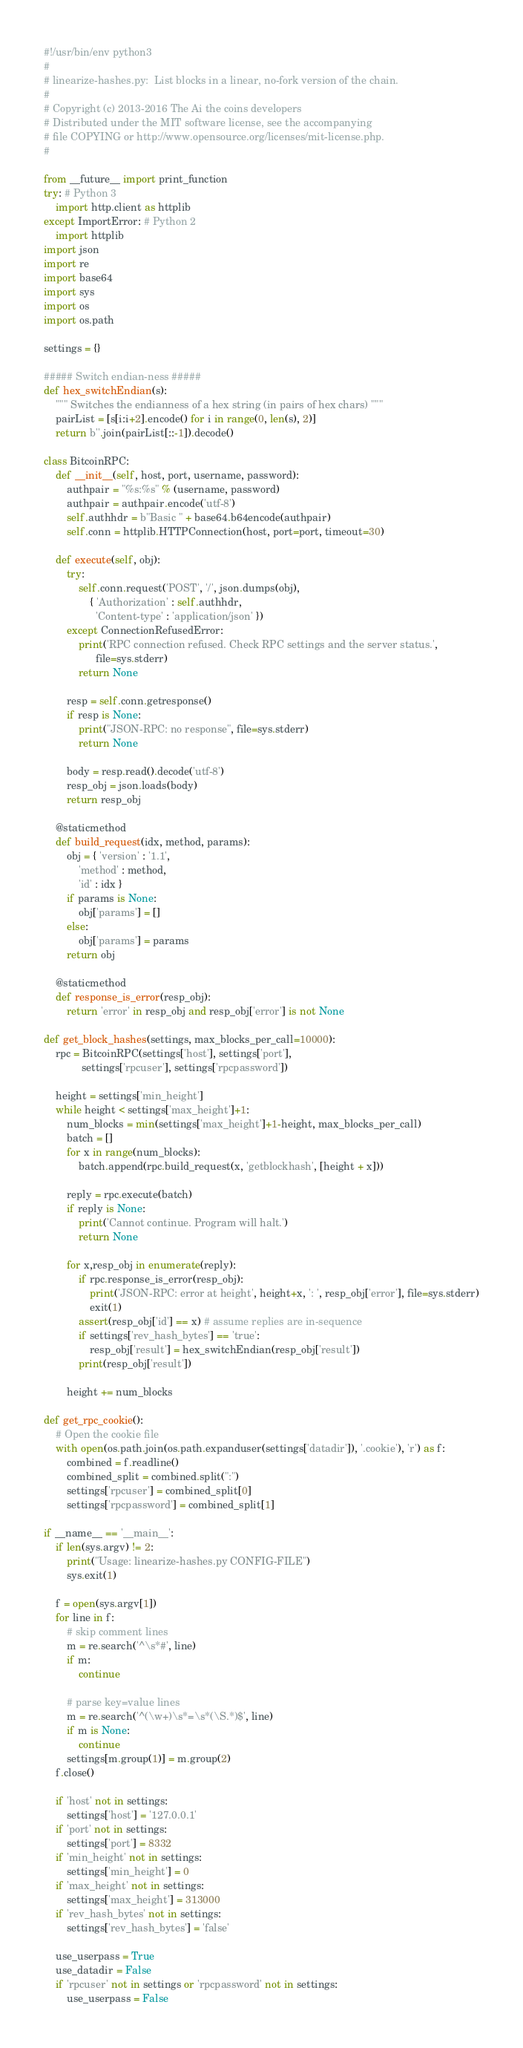Convert code to text. <code><loc_0><loc_0><loc_500><loc_500><_Python_>#!/usr/bin/env python3
#
# linearize-hashes.py:  List blocks in a linear, no-fork version of the chain.
#
# Copyright (c) 2013-2016 The Ai the coins developers
# Distributed under the MIT software license, see the accompanying
# file COPYING or http://www.opensource.org/licenses/mit-license.php.
#

from __future__ import print_function
try: # Python 3
    import http.client as httplib
except ImportError: # Python 2
    import httplib
import json
import re
import base64
import sys
import os
import os.path

settings = {}

##### Switch endian-ness #####
def hex_switchEndian(s):
	""" Switches the endianness of a hex string (in pairs of hex chars) """
	pairList = [s[i:i+2].encode() for i in range(0, len(s), 2)]
	return b''.join(pairList[::-1]).decode()

class BitcoinRPC:
	def __init__(self, host, port, username, password):
		authpair = "%s:%s" % (username, password)
		authpair = authpair.encode('utf-8')
		self.authhdr = b"Basic " + base64.b64encode(authpair)
		self.conn = httplib.HTTPConnection(host, port=port, timeout=30)

	def execute(self, obj):
		try:
			self.conn.request('POST', '/', json.dumps(obj),
				{ 'Authorization' : self.authhdr,
				  'Content-type' : 'application/json' })
		except ConnectionRefusedError:
			print('RPC connection refused. Check RPC settings and the server status.',
			      file=sys.stderr)
			return None

		resp = self.conn.getresponse()
		if resp is None:
			print("JSON-RPC: no response", file=sys.stderr)
			return None

		body = resp.read().decode('utf-8')
		resp_obj = json.loads(body)
		return resp_obj

	@staticmethod
	def build_request(idx, method, params):
		obj = { 'version' : '1.1',
			'method' : method,
			'id' : idx }
		if params is None:
			obj['params'] = []
		else:
			obj['params'] = params
		return obj

	@staticmethod
	def response_is_error(resp_obj):
		return 'error' in resp_obj and resp_obj['error'] is not None

def get_block_hashes(settings, max_blocks_per_call=10000):
	rpc = BitcoinRPC(settings['host'], settings['port'],
			 settings['rpcuser'], settings['rpcpassword'])

	height = settings['min_height']
	while height < settings['max_height']+1:
		num_blocks = min(settings['max_height']+1-height, max_blocks_per_call)
		batch = []
		for x in range(num_blocks):
			batch.append(rpc.build_request(x, 'getblockhash', [height + x]))

		reply = rpc.execute(batch)
		if reply is None:
			print('Cannot continue. Program will halt.')
			return None

		for x,resp_obj in enumerate(reply):
			if rpc.response_is_error(resp_obj):
				print('JSON-RPC: error at height', height+x, ': ', resp_obj['error'], file=sys.stderr)
				exit(1)
			assert(resp_obj['id'] == x) # assume replies are in-sequence
			if settings['rev_hash_bytes'] == 'true':
				resp_obj['result'] = hex_switchEndian(resp_obj['result'])
			print(resp_obj['result'])

		height += num_blocks

def get_rpc_cookie():
	# Open the cookie file
	with open(os.path.join(os.path.expanduser(settings['datadir']), '.cookie'), 'r') as f:
		combined = f.readline()
		combined_split = combined.split(":")
		settings['rpcuser'] = combined_split[0]
		settings['rpcpassword'] = combined_split[1]

if __name__ == '__main__':
	if len(sys.argv) != 2:
		print("Usage: linearize-hashes.py CONFIG-FILE")
		sys.exit(1)

	f = open(sys.argv[1])
	for line in f:
		# skip comment lines
		m = re.search('^\s*#', line)
		if m:
			continue

		# parse key=value lines
		m = re.search('^(\w+)\s*=\s*(\S.*)$', line)
		if m is None:
			continue
		settings[m.group(1)] = m.group(2)
	f.close()

	if 'host' not in settings:
		settings['host'] = '127.0.0.1'
	if 'port' not in settings:
		settings['port'] = 8332
	if 'min_height' not in settings:
		settings['min_height'] = 0
	if 'max_height' not in settings:
		settings['max_height'] = 313000
	if 'rev_hash_bytes' not in settings:
		settings['rev_hash_bytes'] = 'false'

	use_userpass = True
	use_datadir = False
	if 'rpcuser' not in settings or 'rpcpassword' not in settings:
		use_userpass = False</code> 